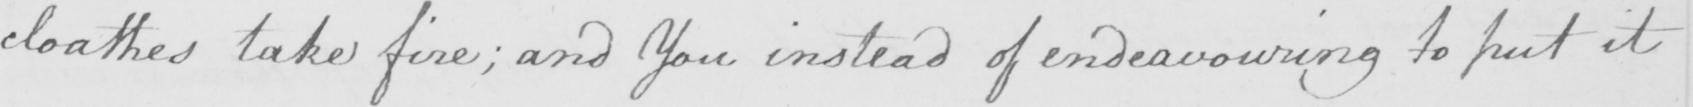Please transcribe the handwritten text in this image. cloathes take fire ; and You instead of endeavouring to put it 